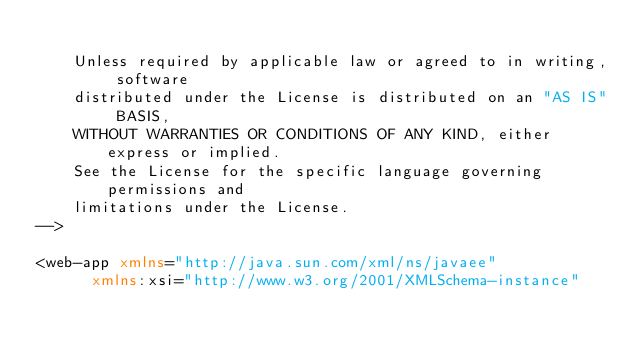Convert code to text. <code><loc_0><loc_0><loc_500><loc_500><_XML_>
    Unless required by applicable law or agreed to in writing, software
    distributed under the License is distributed on an "AS IS" BASIS,
    WITHOUT WARRANTIES OR CONDITIONS OF ANY KIND, either express or implied.
    See the License for the specific language governing permissions and
    limitations under the License.
-->

<web-app xmlns="http://java.sun.com/xml/ns/javaee"
      xmlns:xsi="http://www.w3.org/2001/XMLSchema-instance"</code> 